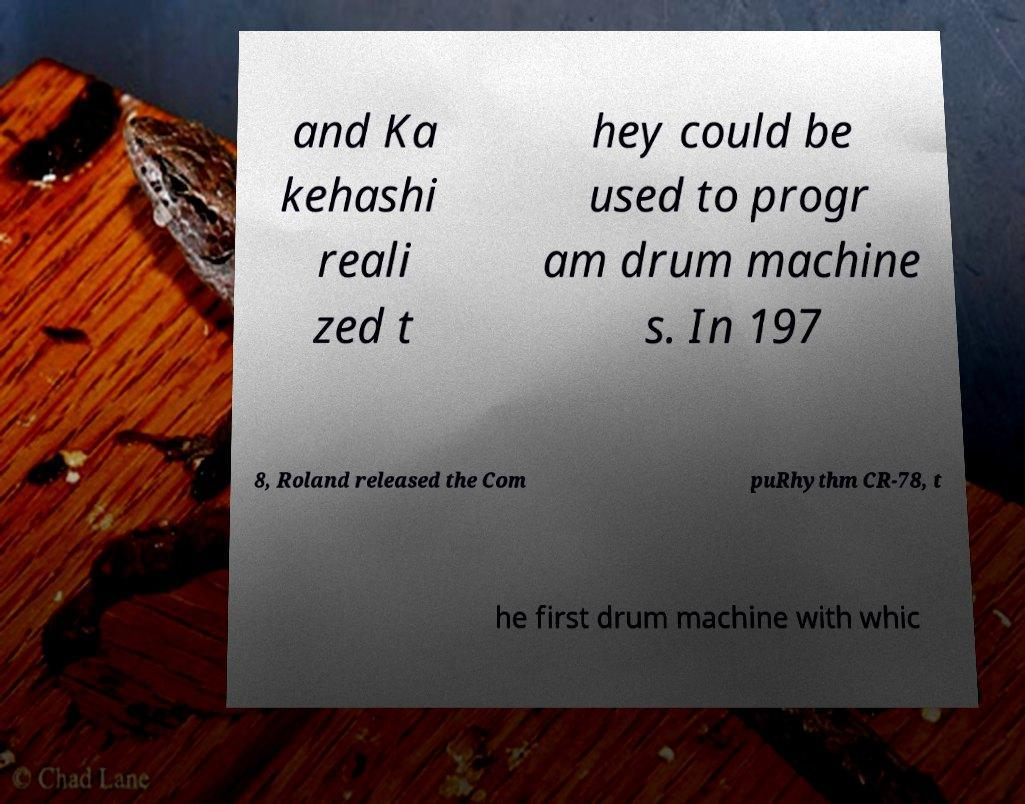I need the written content from this picture converted into text. Can you do that? and Ka kehashi reali zed t hey could be used to progr am drum machine s. In 197 8, Roland released the Com puRhythm CR-78, t he first drum machine with whic 